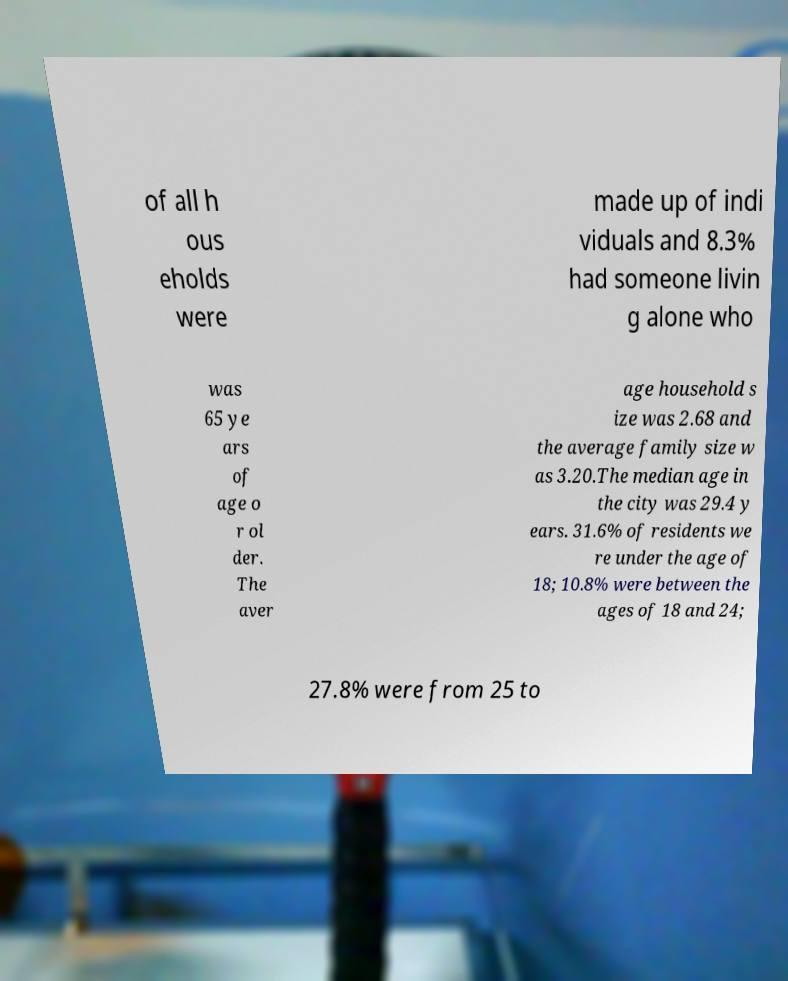Can you accurately transcribe the text from the provided image for me? of all h ous eholds were made up of indi viduals and 8.3% had someone livin g alone who was 65 ye ars of age o r ol der. The aver age household s ize was 2.68 and the average family size w as 3.20.The median age in the city was 29.4 y ears. 31.6% of residents we re under the age of 18; 10.8% were between the ages of 18 and 24; 27.8% were from 25 to 